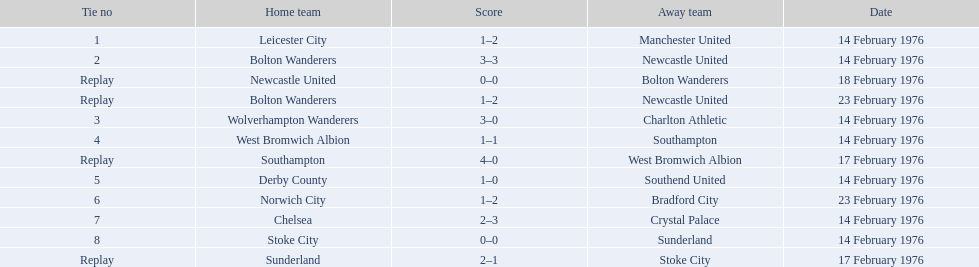Can you list all the teams that played? Leicester City, Manchester United, Bolton Wanderers, Newcastle United, Newcastle United, Bolton Wanderers, Bolton Wanderers, Newcastle United, Wolverhampton Wanderers, Charlton Athletic, West Bromwich Albion, Southampton, Southampton, West Bromwich Albion, Derby County, Southend United, Norwich City, Bradford City, Chelsea, Crystal Palace, Stoke City, Sunderland, Sunderland, Stoke City. Which team won the match? Manchester United, Newcastle United, Wolverhampton Wanderers, Southampton, Derby County, Bradford City, Crystal Palace, Sunderland. What was the final score for manchester united? 1–2. What was wolverhampton wanderers' final score? 3–0. Which team had a superior winning score between the two? Wolverhampton Wanderers. 